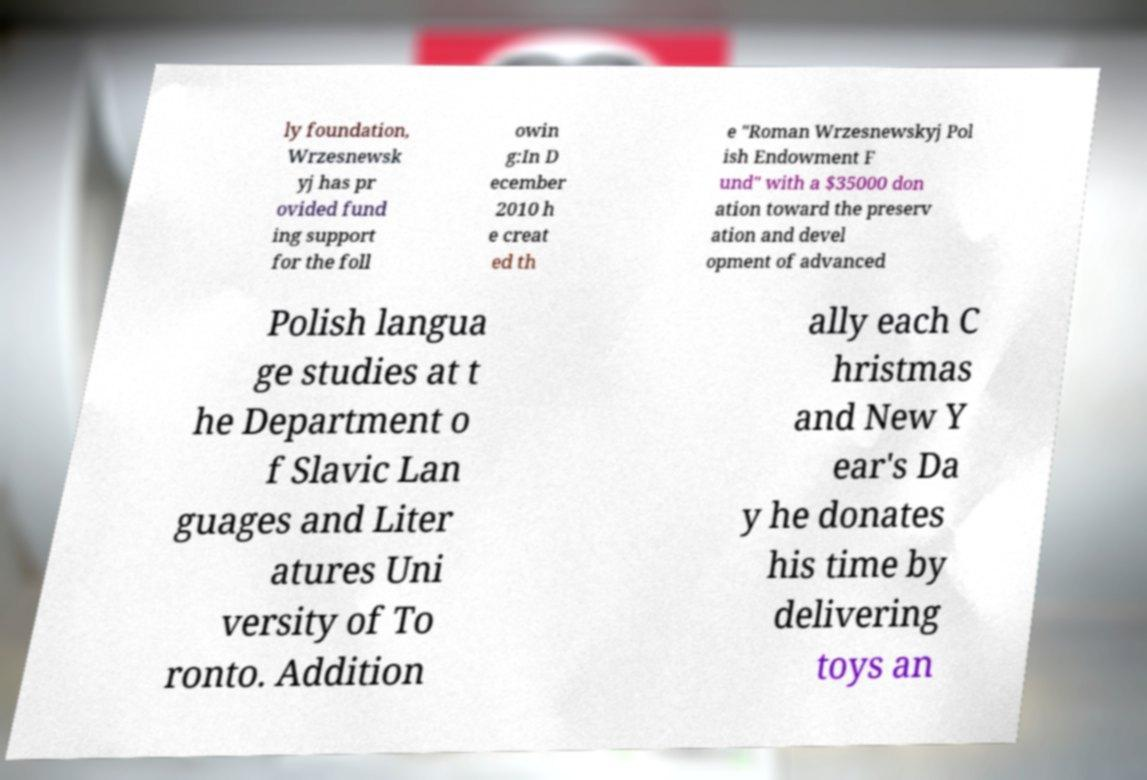Can you accurately transcribe the text from the provided image for me? ly foundation, Wrzesnewsk yj has pr ovided fund ing support for the foll owin g:In D ecember 2010 h e creat ed th e "Roman Wrzesnewskyj Pol ish Endowment F und" with a $35000 don ation toward the preserv ation and devel opment of advanced Polish langua ge studies at t he Department o f Slavic Lan guages and Liter atures Uni versity of To ronto. Addition ally each C hristmas and New Y ear's Da y he donates his time by delivering toys an 